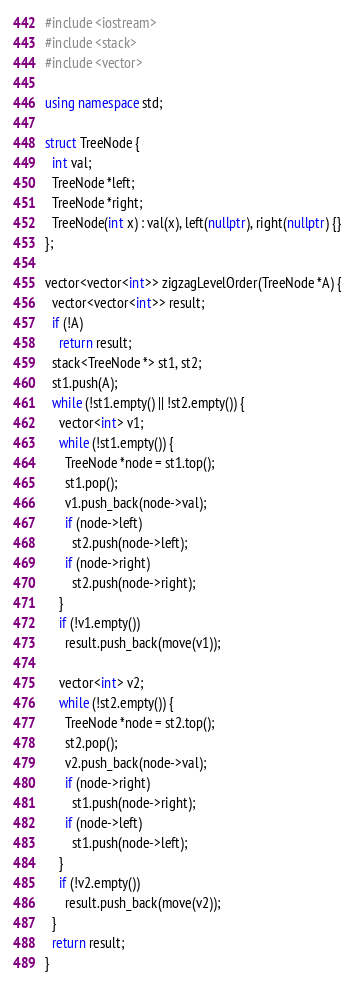Convert code to text. <code><loc_0><loc_0><loc_500><loc_500><_C++_>#include <iostream>
#include <stack>
#include <vector>

using namespace std;

struct TreeNode {
  int val;
  TreeNode *left;
  TreeNode *right;
  TreeNode(int x) : val(x), left(nullptr), right(nullptr) {}
};

vector<vector<int>> zigzagLevelOrder(TreeNode *A) {
  vector<vector<int>> result;
  if (!A)
    return result;
  stack<TreeNode *> st1, st2;
  st1.push(A);
  while (!st1.empty() || !st2.empty()) {
    vector<int> v1;
    while (!st1.empty()) {
      TreeNode *node = st1.top();
      st1.pop();
      v1.push_back(node->val);
      if (node->left)
        st2.push(node->left);
      if (node->right)
        st2.push(node->right);
    }
    if (!v1.empty())
      result.push_back(move(v1));

    vector<int> v2;
    while (!st2.empty()) {
      TreeNode *node = st2.top();
      st2.pop();
      v2.push_back(node->val);
      if (node->right)
        st1.push(node->right);
      if (node->left)
        st1.push(node->left);
    }
    if (!v2.empty())
      result.push_back(move(v2));
  }
  return result;
}
</code> 